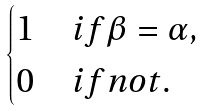<formula> <loc_0><loc_0><loc_500><loc_500>\begin{cases} 1 & i f \beta = \alpha , \\ 0 & i f n o t . \end{cases}</formula> 